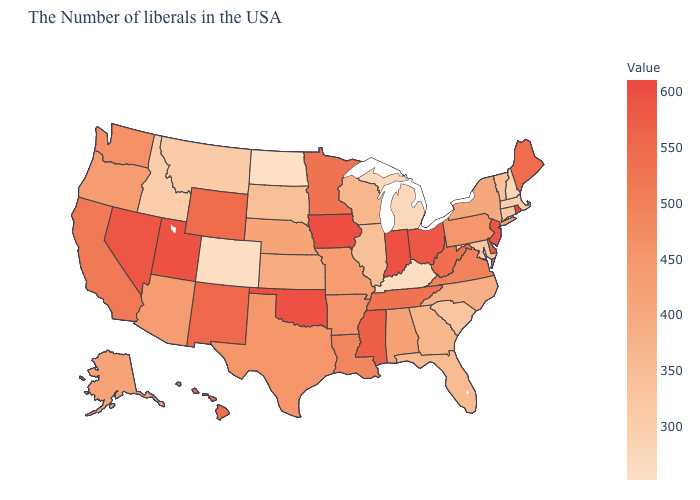Does Maryland have a lower value than West Virginia?
Write a very short answer. Yes. Does Rhode Island have the highest value in the USA?
Be succinct. Yes. Does Nevada have the highest value in the West?
Answer briefly. No. 